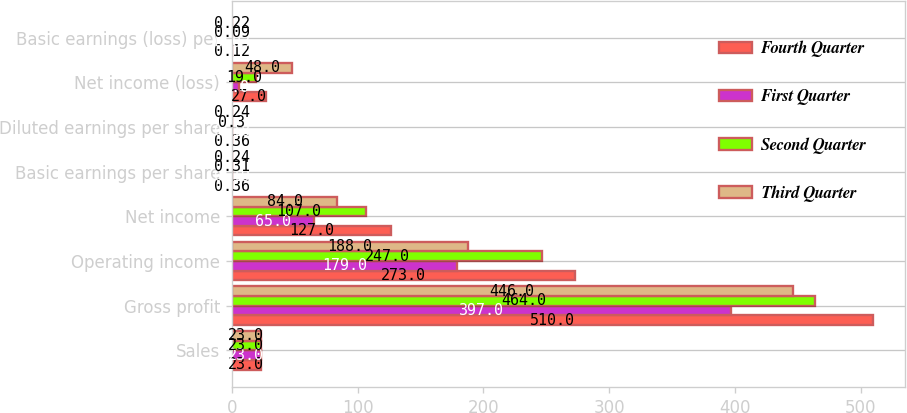Convert chart to OTSL. <chart><loc_0><loc_0><loc_500><loc_500><stacked_bar_chart><ecel><fcel>Sales<fcel>Gross profit<fcel>Operating income<fcel>Net income<fcel>Basic earnings per share<fcel>Diluted earnings per share<fcel>Net income (loss)<fcel>Basic earnings (loss) per<nl><fcel>Fourth Quarter<fcel>23<fcel>510<fcel>273<fcel>127<fcel>0.36<fcel>0.36<fcel>27<fcel>0.12<nl><fcel>First Quarter<fcel>23<fcel>397<fcel>179<fcel>65<fcel>0.19<fcel>0.18<fcel>6<fcel>0.03<nl><fcel>Second Quarter<fcel>23<fcel>464<fcel>247<fcel>107<fcel>0.31<fcel>0.3<fcel>19<fcel>0.09<nl><fcel>Third Quarter<fcel>23<fcel>446<fcel>188<fcel>84<fcel>0.24<fcel>0.24<fcel>48<fcel>0.22<nl></chart> 